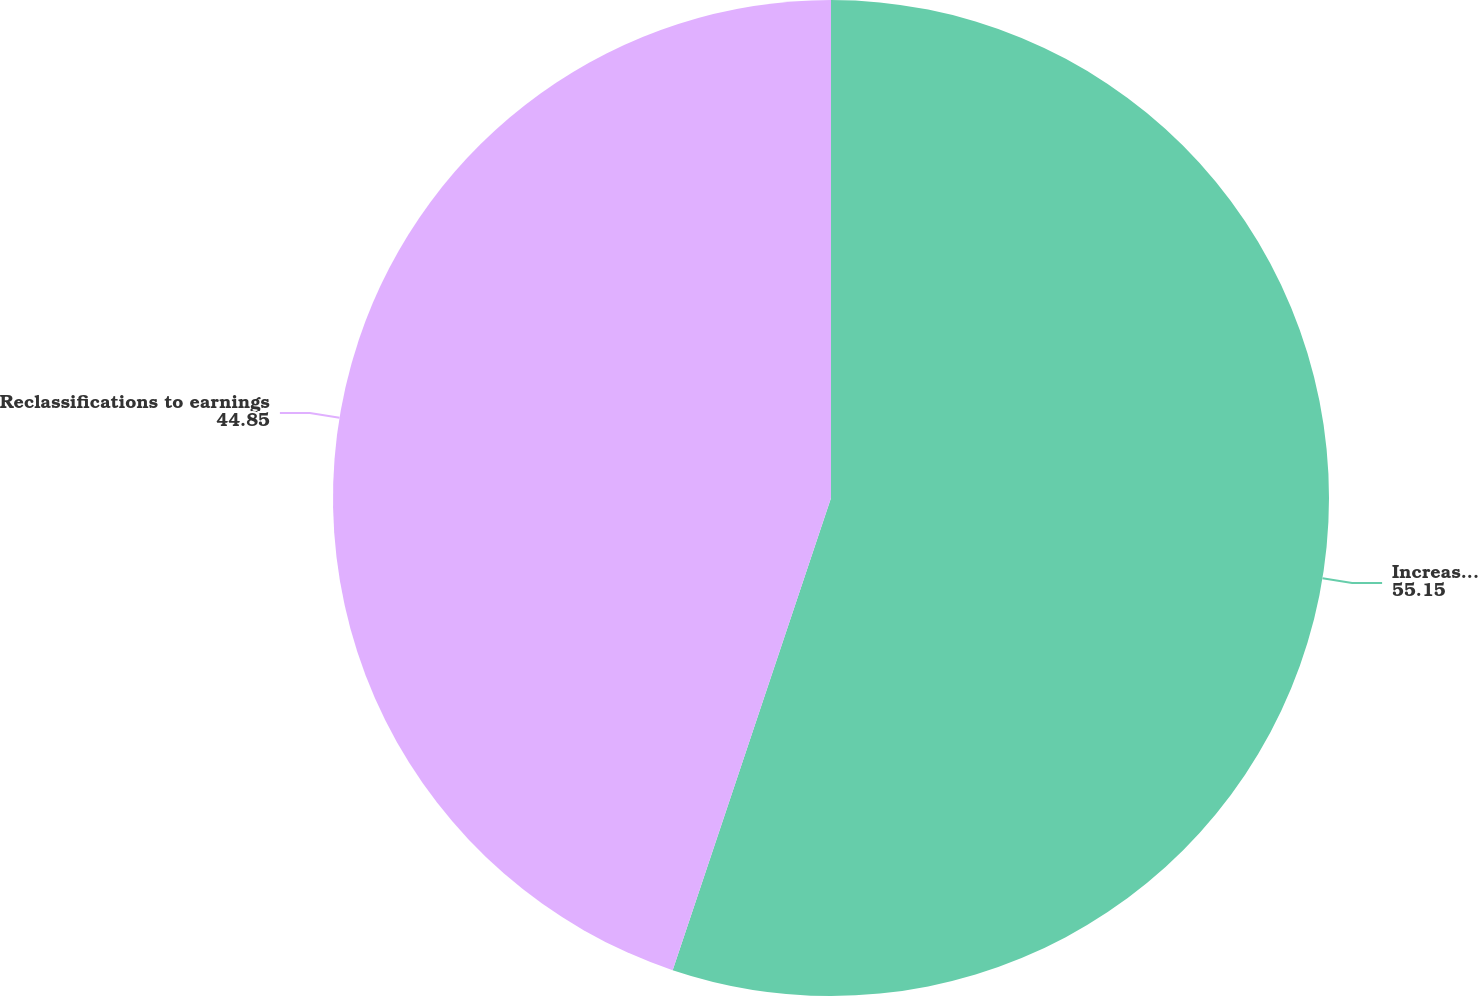Convert chart to OTSL. <chart><loc_0><loc_0><loc_500><loc_500><pie_chart><fcel>Increase (decrease) in fair<fcel>Reclassifications to earnings<nl><fcel>55.15%<fcel>44.85%<nl></chart> 